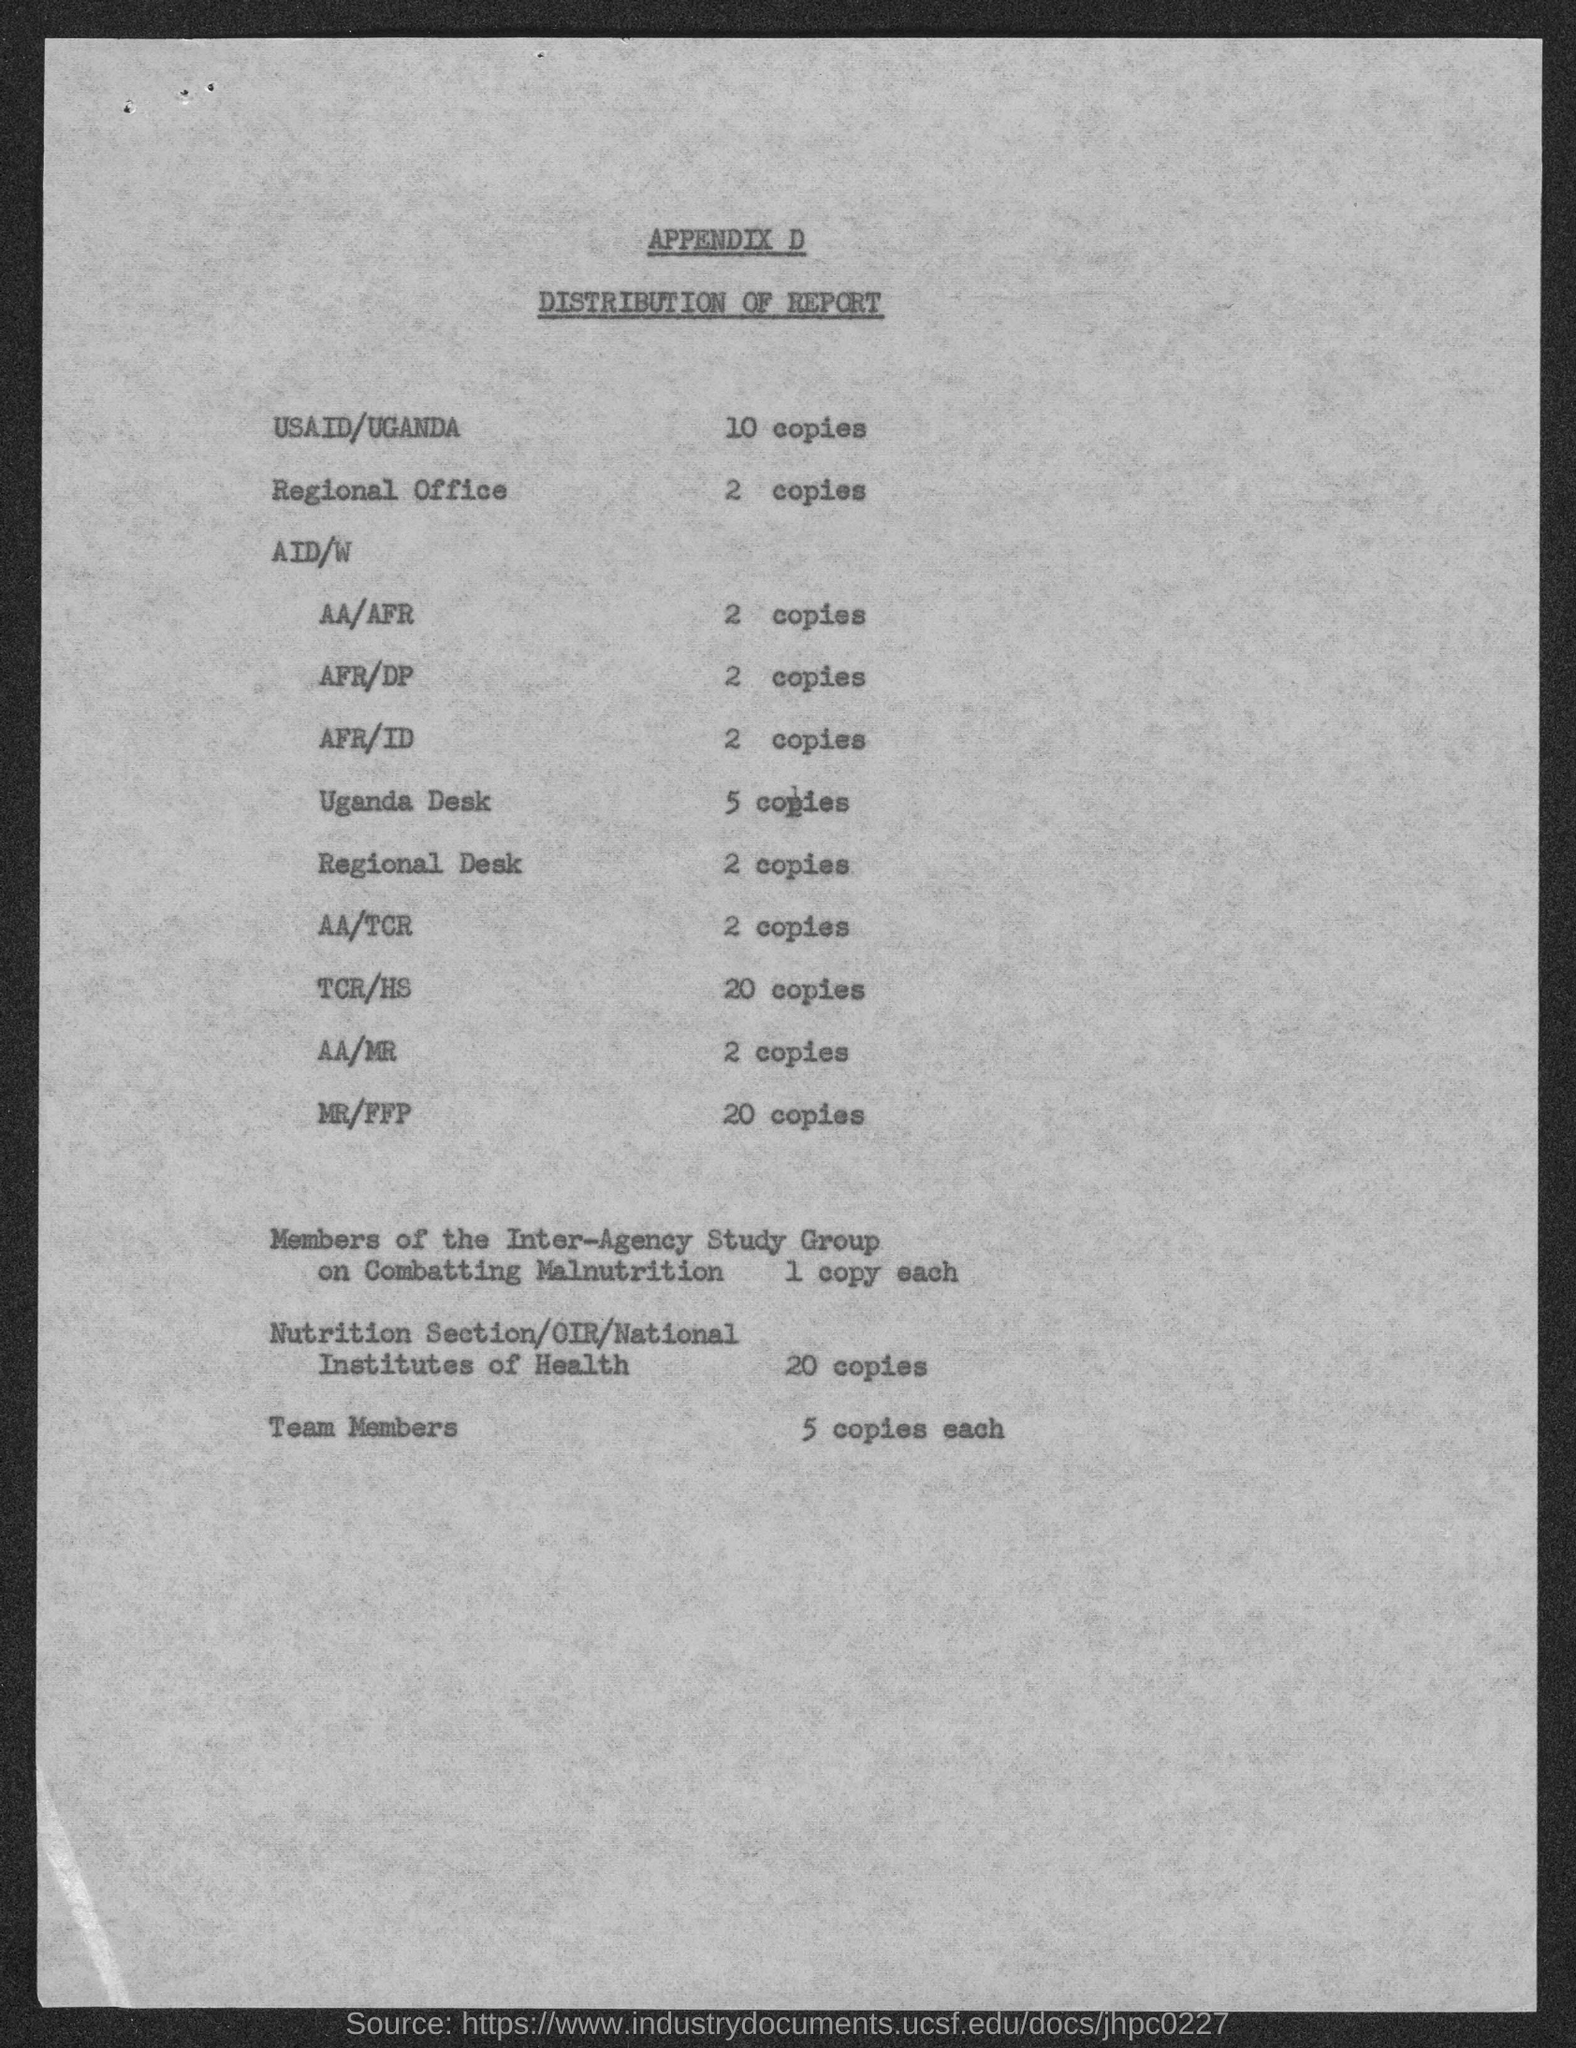Highlight a few significant elements in this photo. According to the information provided, approximately 10 copies of the report were distributed in USAID/UGANDA. The distribution of the report in the regional office was limited to two copies. The number of copies of the report distributed in the regional desk is two. Five copies of the report are distributed to each team member. The number of copies of the report distributed in the Uganda Desk is five. 